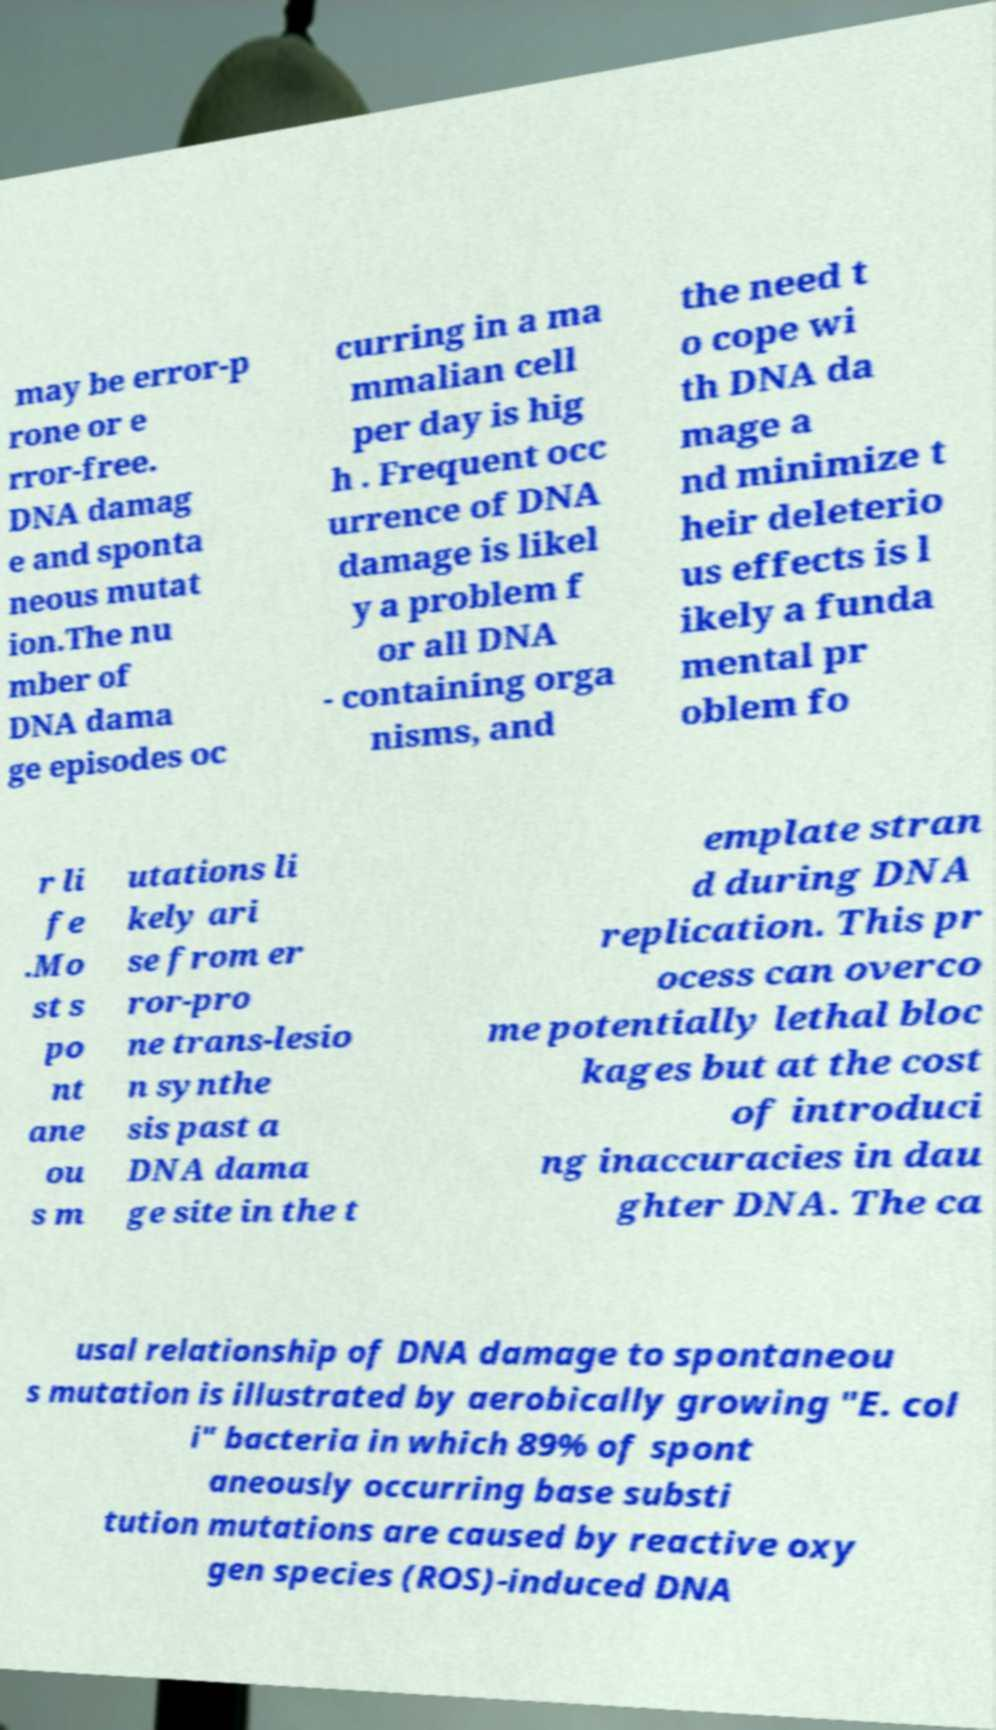Please identify and transcribe the text found in this image. may be error-p rone or e rror-free. DNA damag e and sponta neous mutat ion.The nu mber of DNA dama ge episodes oc curring in a ma mmalian cell per day is hig h . Frequent occ urrence of DNA damage is likel y a problem f or all DNA - containing orga nisms, and the need t o cope wi th DNA da mage a nd minimize t heir deleterio us effects is l ikely a funda mental pr oblem fo r li fe .Mo st s po nt ane ou s m utations li kely ari se from er ror-pro ne trans-lesio n synthe sis past a DNA dama ge site in the t emplate stran d during DNA replication. This pr ocess can overco me potentially lethal bloc kages but at the cost of introduci ng inaccuracies in dau ghter DNA. The ca usal relationship of DNA damage to spontaneou s mutation is illustrated by aerobically growing "E. col i" bacteria in which 89% of spont aneously occurring base substi tution mutations are caused by reactive oxy gen species (ROS)-induced DNA 